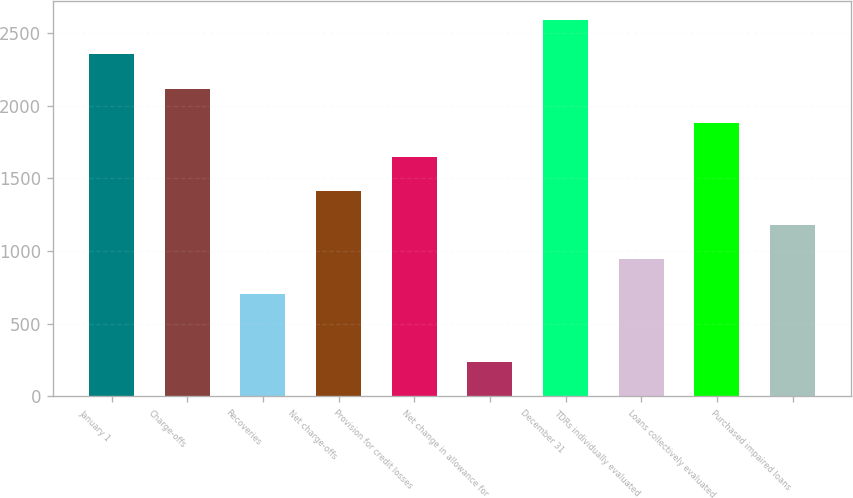<chart> <loc_0><loc_0><loc_500><loc_500><bar_chart><fcel>January 1<fcel>Charge-offs<fcel>Recoveries<fcel>Net charge-offs<fcel>Provision for credit losses<fcel>Net change in allowance for<fcel>December 31<fcel>TDRs individually evaluated<fcel>Loans collectively evaluated<fcel>Purchased impaired loans<nl><fcel>2352.03<fcel>2117.16<fcel>707.94<fcel>1412.55<fcel>1647.42<fcel>238.2<fcel>2586.9<fcel>942.81<fcel>1882.29<fcel>1177.68<nl></chart> 